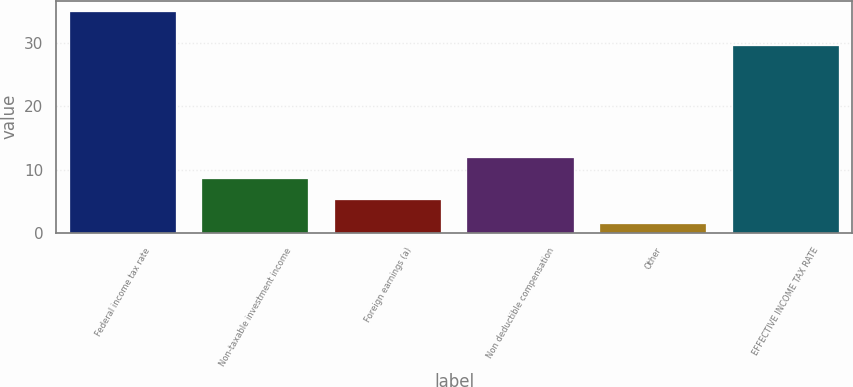Convert chart to OTSL. <chart><loc_0><loc_0><loc_500><loc_500><bar_chart><fcel>Federal income tax rate<fcel>Non-taxable investment income<fcel>Foreign earnings (a)<fcel>Non deductible compensation<fcel>Other<fcel>EFFECTIVE INCOME TAX RATE<nl><fcel>35<fcel>8.56<fcel>5.2<fcel>11.92<fcel>1.4<fcel>29.6<nl></chart> 